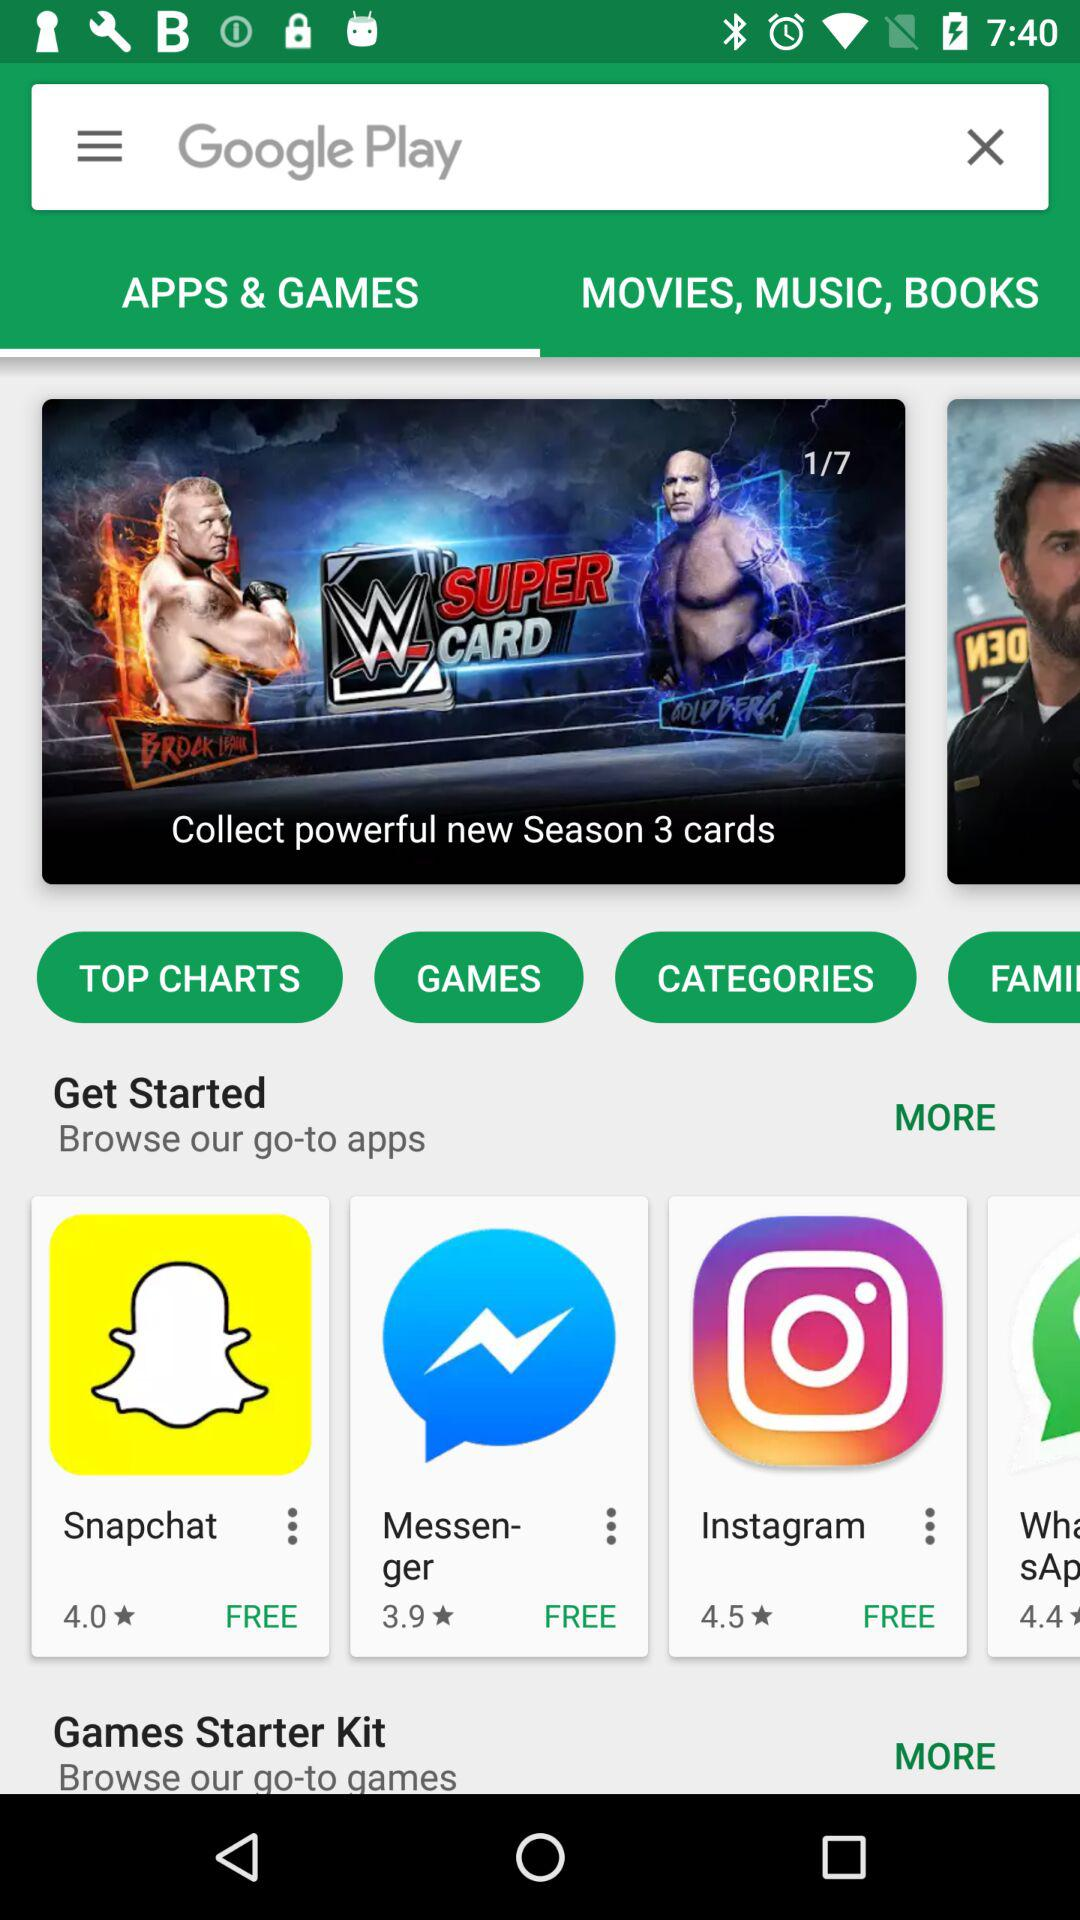How many apps are in the top charts section?
Answer the question using a single word or phrase. 4 